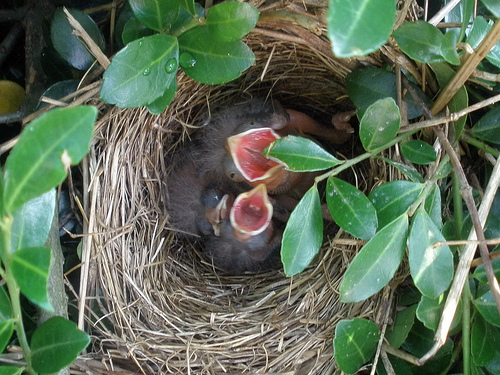Describe the materials used to build this nest. This nest appears to be constructed primarily from twigs and grass, materials commonly used by birds. The structure is designed to cradle the chicks safely and provide insulation. 